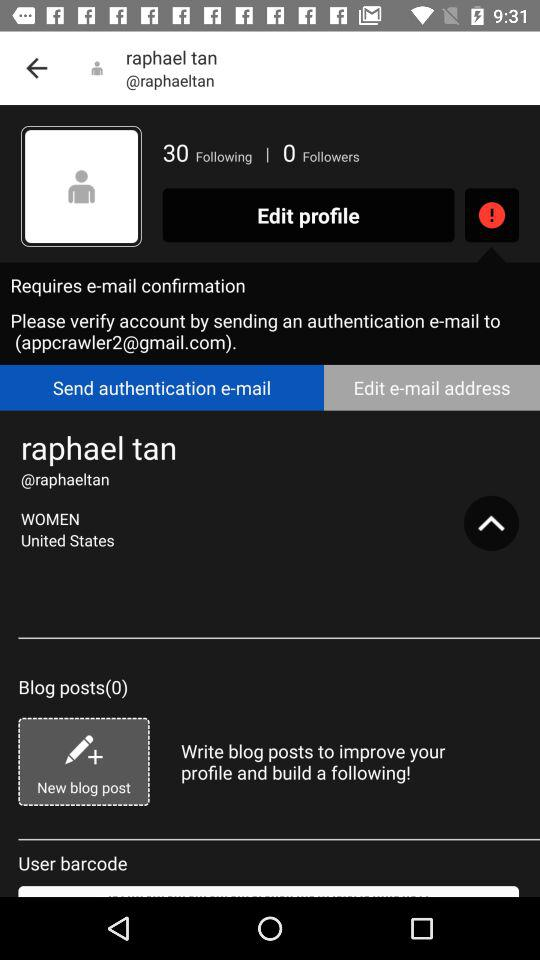How many followers does the user have?
Answer the question using a single word or phrase. 0 